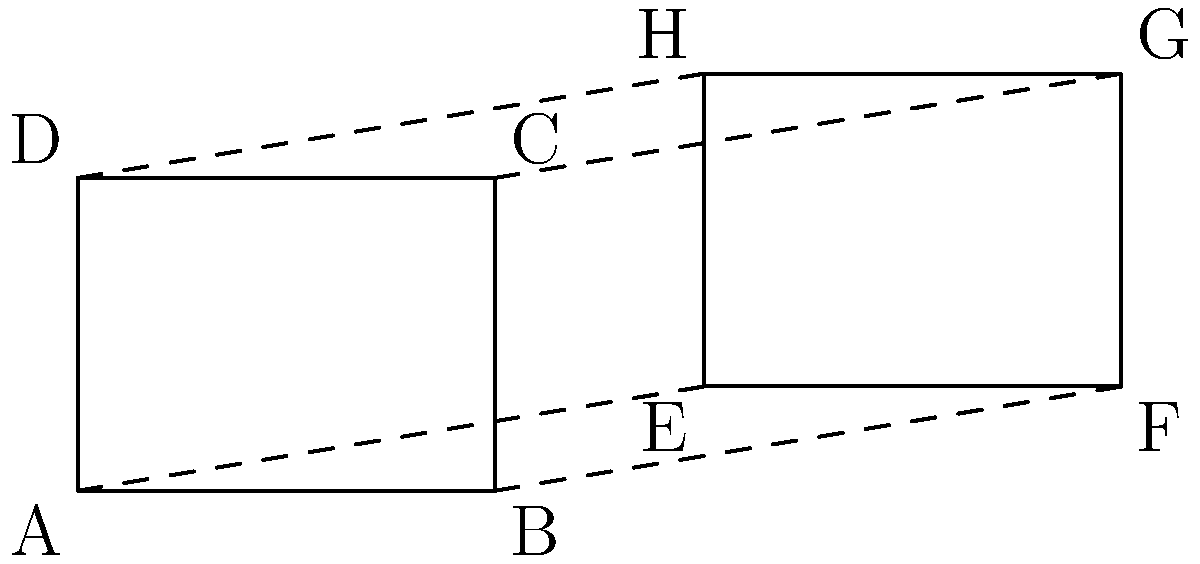In the diagram above, quadrilateral $ABCD$ and quadrilateral $EFGH$ are shown. Describe a sequence of transformations that would prove these quadrilaterals are congruent. How does this relate to the importance of computer science education in preparing students for future careers? To prove that quadrilaterals $ABCD$ and $EFGH$ are congruent using transformations, we can follow these steps:

1. Translation: Move quadrilateral $ABCD$ to the right by 6 units. This aligns point $A$ with point $E$.

2. Dilation: Expand quadrilateral $ABCD$ by a scale factor of $\frac{10-6}{4-0} = 1$. This step is actually unnecessary since the scale factor is 1, indicating that no dilation is needed.

3. Rotation: Rotate the translated quadrilateral $ABCD$ around point $E$ by 0°. Again, this step is unnecessary as no rotation is needed.

These transformations map quadrilateral $ABCD$ exactly onto quadrilateral $EFGH$, proving they are congruent.

This problem relates to computer science education in several ways:

1. Algorithmic thinking: The sequence of transformations is similar to an algorithm, a fundamental concept in computer science.

2. Spatial reasoning: Understanding and visualizing transformations is crucial in fields like computer graphics and robotics.

3. Problem-solving: Breaking down the problem into steps (translation, dilation, rotation) mirrors the process of decomposing complex problems in programming.

4. Precision: The exact measurements and transformations reflect the precision required in coding and data analysis.

5. Coordinate systems: The use of a coordinate plane is analogous to how computers represent graphical information.

By exposing students to such problems, we prepare them for future careers that increasingly rely on computational thinking and spatial reasoning skills, which are core components of computer science education.
Answer: Translation 6 units right; no dilation; no rotation 